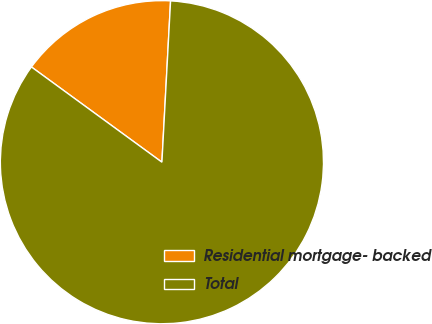Convert chart to OTSL. <chart><loc_0><loc_0><loc_500><loc_500><pie_chart><fcel>Residential mortgage- backed<fcel>Total<nl><fcel>15.82%<fcel>84.18%<nl></chart> 